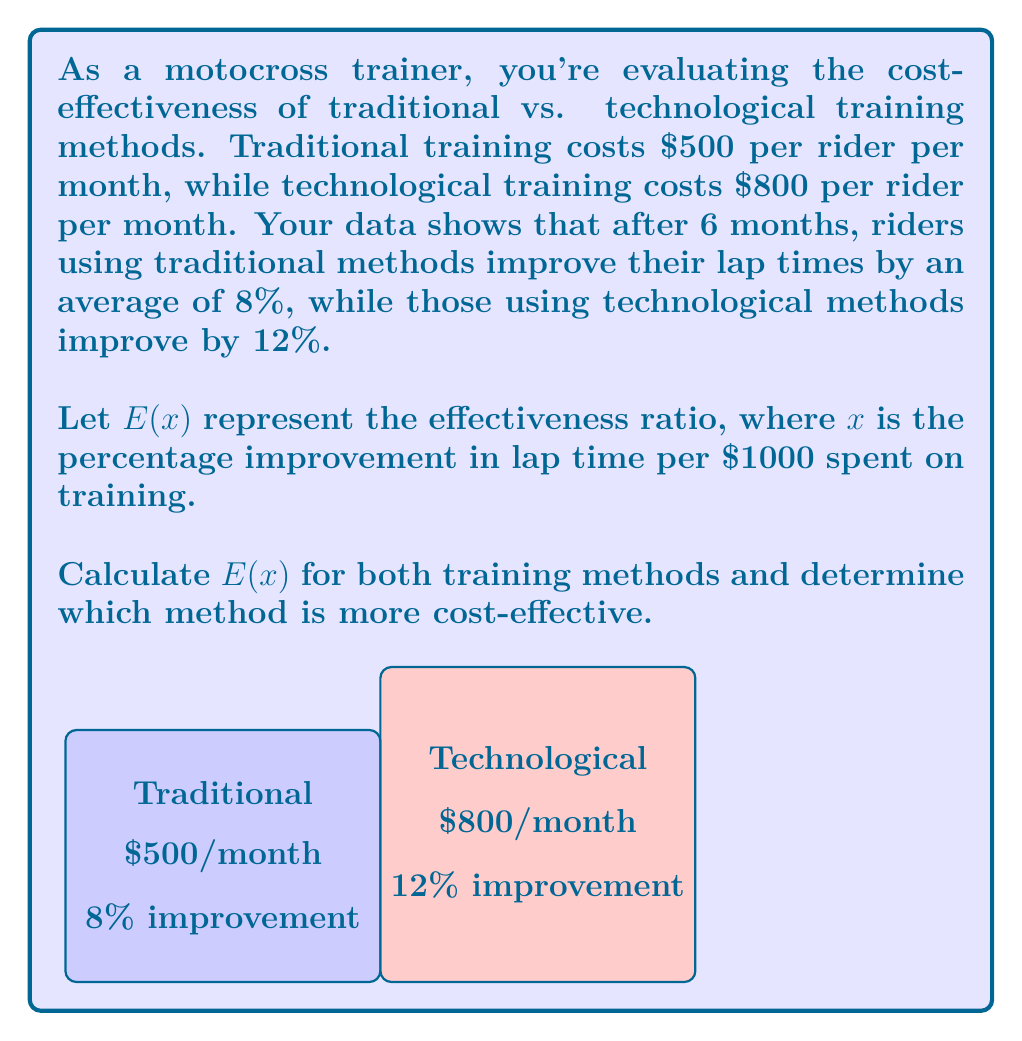Can you solve this math problem? Let's approach this step-by-step:

1) First, we need to calculate the total cost for 6 months for each method:
   Traditional: $500 * 6 = $3000
   Technological: $800 * 6 = $4800

2) Now, we can calculate the effectiveness ratio $E(x)$ for each method:

   For traditional method:
   $$E(x)_{\text{traditional}} = \frac{\text{Percentage improvement}}{\text{Cost per $1000}} = \frac{8\%}{(3000/1000)} = \frac{8}{3} = 2.67\% \text{ per $1000}$$

   For technological method:
   $$E(x)_{\text{technological}} = \frac{\text{Percentage improvement}}{\text{Cost per $1000}} = \frac{12\%}{(4800/1000)} = \frac{12}{4.8} = 2.5\% \text{ per $1000}$$

3) Comparing the two $E(x)$ values:
   $E(x)_{\text{traditional}} = 2.67\% \text{ per $1000} > E(x)_{\text{technological}} = 2.5\% \text{ per $1000}$

Therefore, the traditional method is more cost-effective as it provides a higher percentage improvement per $1000 spent.
Answer: Traditional method; $E(x)_{\text{traditional}} = 2.67\% > E(x)_{\text{technological}} = 2.5\%$ 